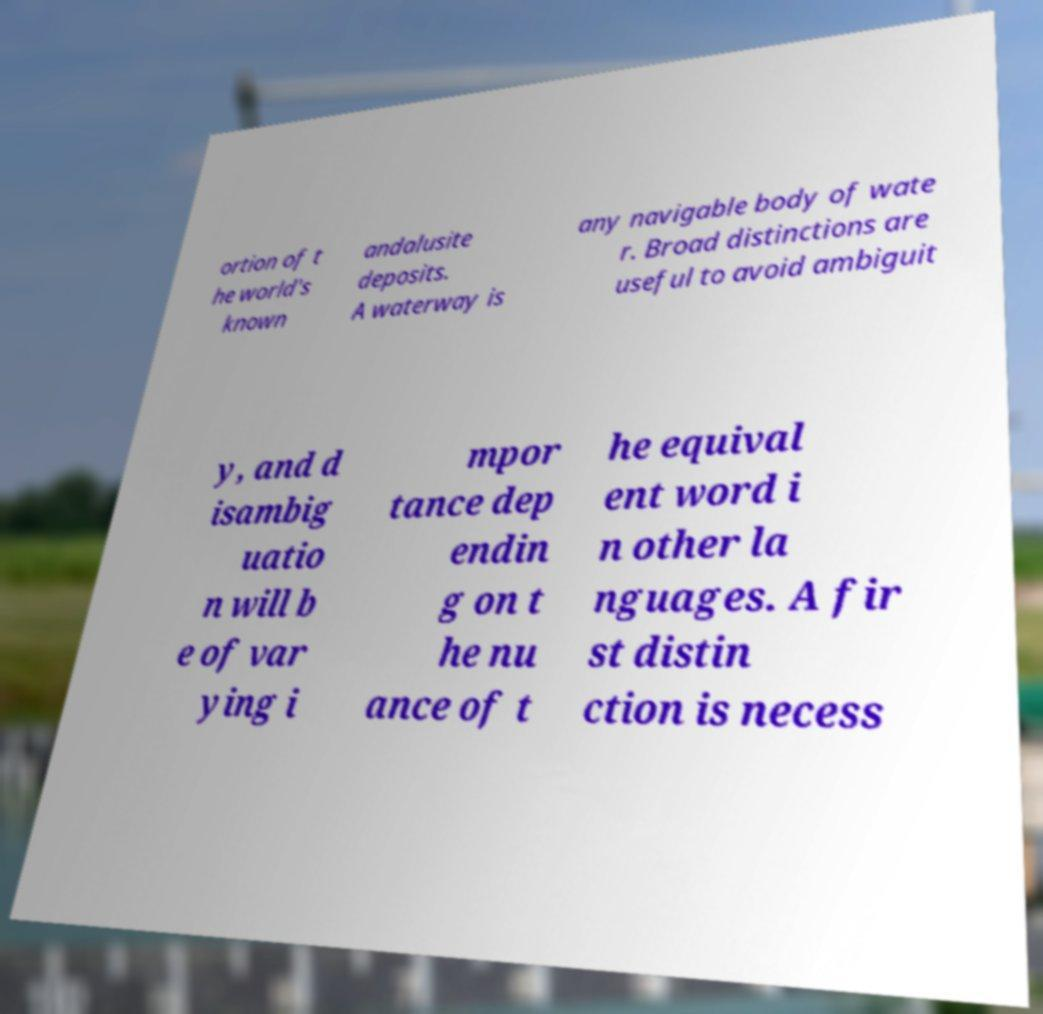Can you accurately transcribe the text from the provided image for me? ortion of t he world's known andalusite deposits. A waterway is any navigable body of wate r. Broad distinctions are useful to avoid ambiguit y, and d isambig uatio n will b e of var ying i mpor tance dep endin g on t he nu ance of t he equival ent word i n other la nguages. A fir st distin ction is necess 